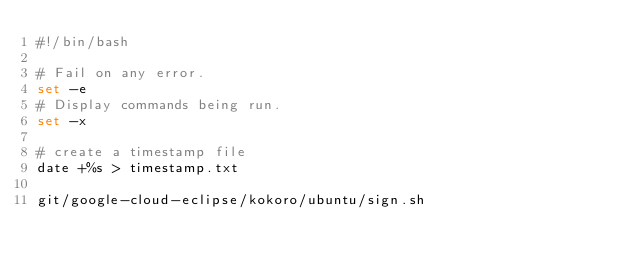<code> <loc_0><loc_0><loc_500><loc_500><_Bash_>#!/bin/bash

# Fail on any error.
set -e
# Display commands being run.
set -x

# create a timestamp file
date +%s > timestamp.txt

git/google-cloud-eclipse/kokoro/ubuntu/sign.sh


</code> 